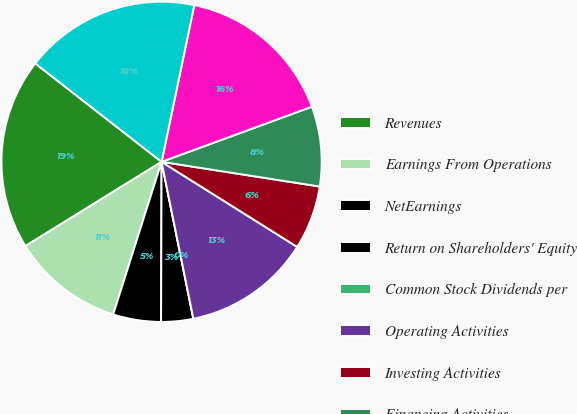Convert chart. <chart><loc_0><loc_0><loc_500><loc_500><pie_chart><fcel>Revenues<fcel>Earnings From Operations<fcel>NetEarnings<fcel>Return on Shareholders' Equity<fcel>Common Stock Dividends per<fcel>Operating Activities<fcel>Investing Activities<fcel>Financing Activities<fcel>Cash and Investments<fcel>Total Assets<nl><fcel>19.35%<fcel>11.29%<fcel>4.84%<fcel>3.23%<fcel>0.0%<fcel>12.9%<fcel>6.45%<fcel>8.06%<fcel>16.13%<fcel>17.74%<nl></chart> 